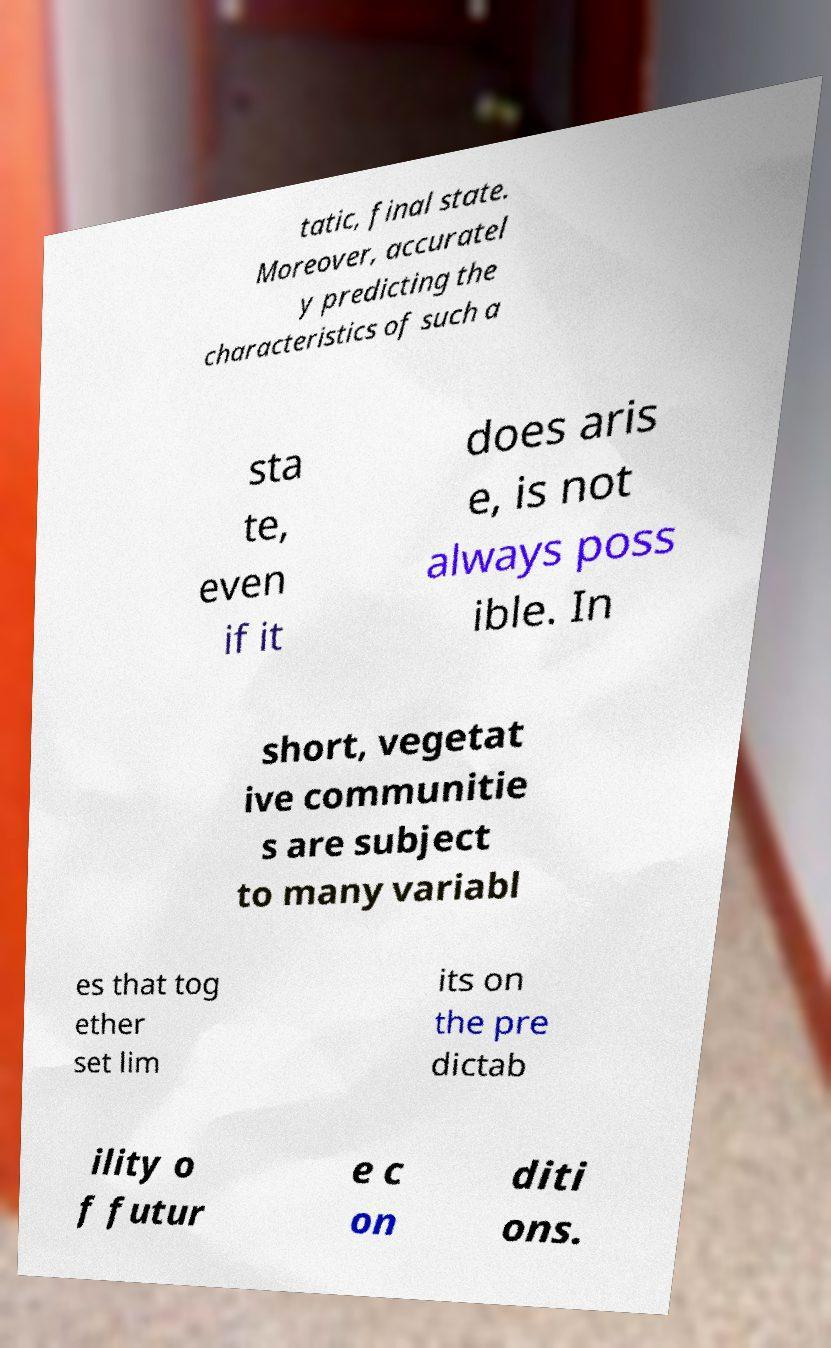What messages or text are displayed in this image? I need them in a readable, typed format. tatic, final state. Moreover, accuratel y predicting the characteristics of such a sta te, even if it does aris e, is not always poss ible. In short, vegetat ive communitie s are subject to many variabl es that tog ether set lim its on the pre dictab ility o f futur e c on diti ons. 